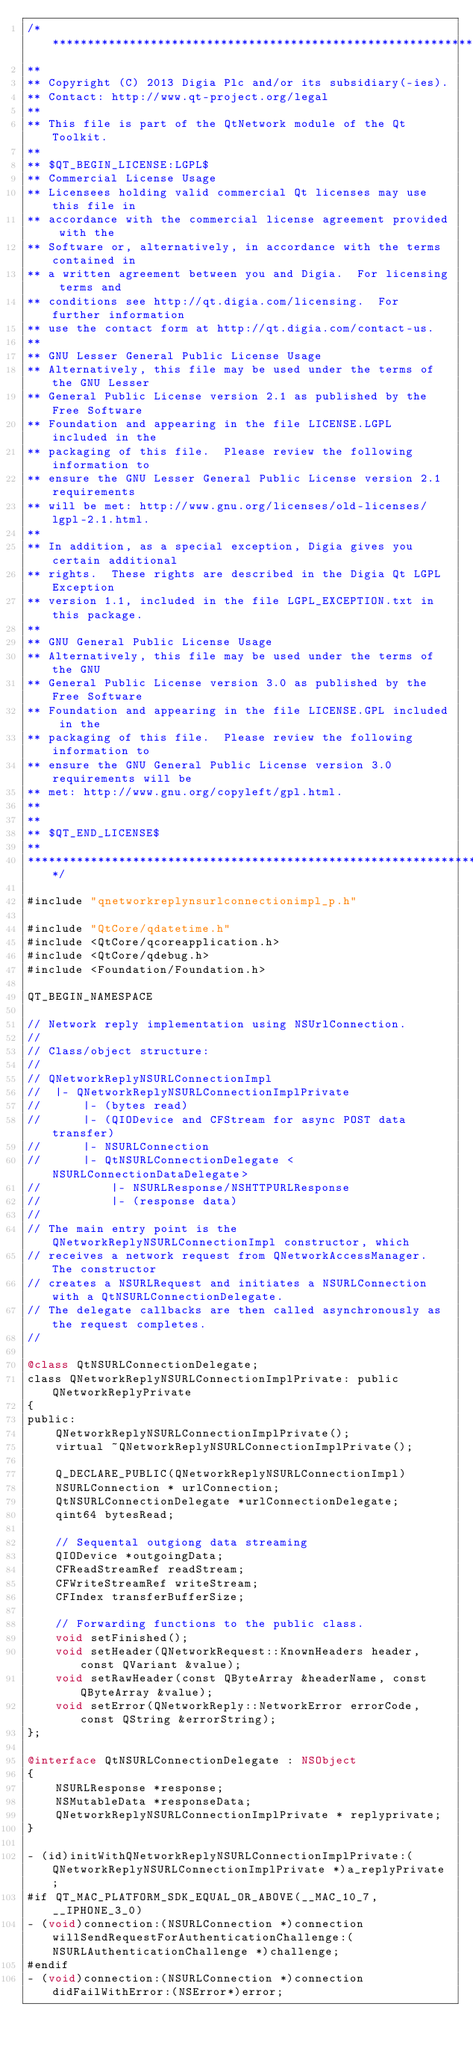Convert code to text. <code><loc_0><loc_0><loc_500><loc_500><_ObjectiveC_>/****************************************************************************
**
** Copyright (C) 2013 Digia Plc and/or its subsidiary(-ies).
** Contact: http://www.qt-project.org/legal
**
** This file is part of the QtNetwork module of the Qt Toolkit.
**
** $QT_BEGIN_LICENSE:LGPL$
** Commercial License Usage
** Licensees holding valid commercial Qt licenses may use this file in
** accordance with the commercial license agreement provided with the
** Software or, alternatively, in accordance with the terms contained in
** a written agreement between you and Digia.  For licensing terms and
** conditions see http://qt.digia.com/licensing.  For further information
** use the contact form at http://qt.digia.com/contact-us.
**
** GNU Lesser General Public License Usage
** Alternatively, this file may be used under the terms of the GNU Lesser
** General Public License version 2.1 as published by the Free Software
** Foundation and appearing in the file LICENSE.LGPL included in the
** packaging of this file.  Please review the following information to
** ensure the GNU Lesser General Public License version 2.1 requirements
** will be met: http://www.gnu.org/licenses/old-licenses/lgpl-2.1.html.
**
** In addition, as a special exception, Digia gives you certain additional
** rights.  These rights are described in the Digia Qt LGPL Exception
** version 1.1, included in the file LGPL_EXCEPTION.txt in this package.
**
** GNU General Public License Usage
** Alternatively, this file may be used under the terms of the GNU
** General Public License version 3.0 as published by the Free Software
** Foundation and appearing in the file LICENSE.GPL included in the
** packaging of this file.  Please review the following information to
** ensure the GNU General Public License version 3.0 requirements will be
** met: http://www.gnu.org/copyleft/gpl.html.
**
**
** $QT_END_LICENSE$
**
****************************************************************************/

#include "qnetworkreplynsurlconnectionimpl_p.h"

#include "QtCore/qdatetime.h"
#include <QtCore/qcoreapplication.h>
#include <QtCore/qdebug.h>
#include <Foundation/Foundation.h>

QT_BEGIN_NAMESPACE

// Network reply implementation using NSUrlConnection.
//
// Class/object structure:
//
// QNetworkReplyNSURLConnectionImpl
//  |- QNetworkReplyNSURLConnectionImplPrivate
//      |- (bytes read)
//      |- (QIODevice and CFStream for async POST data transfer)
//      |- NSURLConnection
//      |- QtNSURLConnectionDelegate <NSURLConnectionDataDelegate>
//          |- NSURLResponse/NSHTTPURLResponse
//          |- (response data)
//
// The main entry point is the QNetworkReplyNSURLConnectionImpl constructor, which
// receives a network request from QNetworkAccessManager. The constructor
// creates a NSURLRequest and initiates a NSURLConnection with a QtNSURLConnectionDelegate.
// The delegate callbacks are then called asynchronously as the request completes.
//

@class QtNSURLConnectionDelegate;
class QNetworkReplyNSURLConnectionImplPrivate: public QNetworkReplyPrivate
{
public:
    QNetworkReplyNSURLConnectionImplPrivate();
    virtual ~QNetworkReplyNSURLConnectionImplPrivate();

    Q_DECLARE_PUBLIC(QNetworkReplyNSURLConnectionImpl)
    NSURLConnection * urlConnection;
    QtNSURLConnectionDelegate *urlConnectionDelegate;
    qint64 bytesRead;

    // Sequental outgiong data streaming
    QIODevice *outgoingData;
    CFReadStreamRef readStream;
    CFWriteStreamRef writeStream;
    CFIndex transferBufferSize;

    // Forwarding functions to the public class.
    void setFinished();
    void setHeader(QNetworkRequest::KnownHeaders header, const QVariant &value);
    void setRawHeader(const QByteArray &headerName, const QByteArray &value);
    void setError(QNetworkReply::NetworkError errorCode, const QString &errorString);
};

@interface QtNSURLConnectionDelegate : NSObject
{
    NSURLResponse *response;
    NSMutableData *responseData;
    QNetworkReplyNSURLConnectionImplPrivate * replyprivate;
}

- (id)initWithQNetworkReplyNSURLConnectionImplPrivate:(QNetworkReplyNSURLConnectionImplPrivate *)a_replyPrivate ;
#if QT_MAC_PLATFORM_SDK_EQUAL_OR_ABOVE(__MAC_10_7, __IPHONE_3_0)
- (void)connection:(NSURLConnection *)connection willSendRequestForAuthenticationChallenge:(NSURLAuthenticationChallenge *)challenge;
#endif
- (void)connection:(NSURLConnection *)connection didFailWithError:(NSError*)error;</code> 